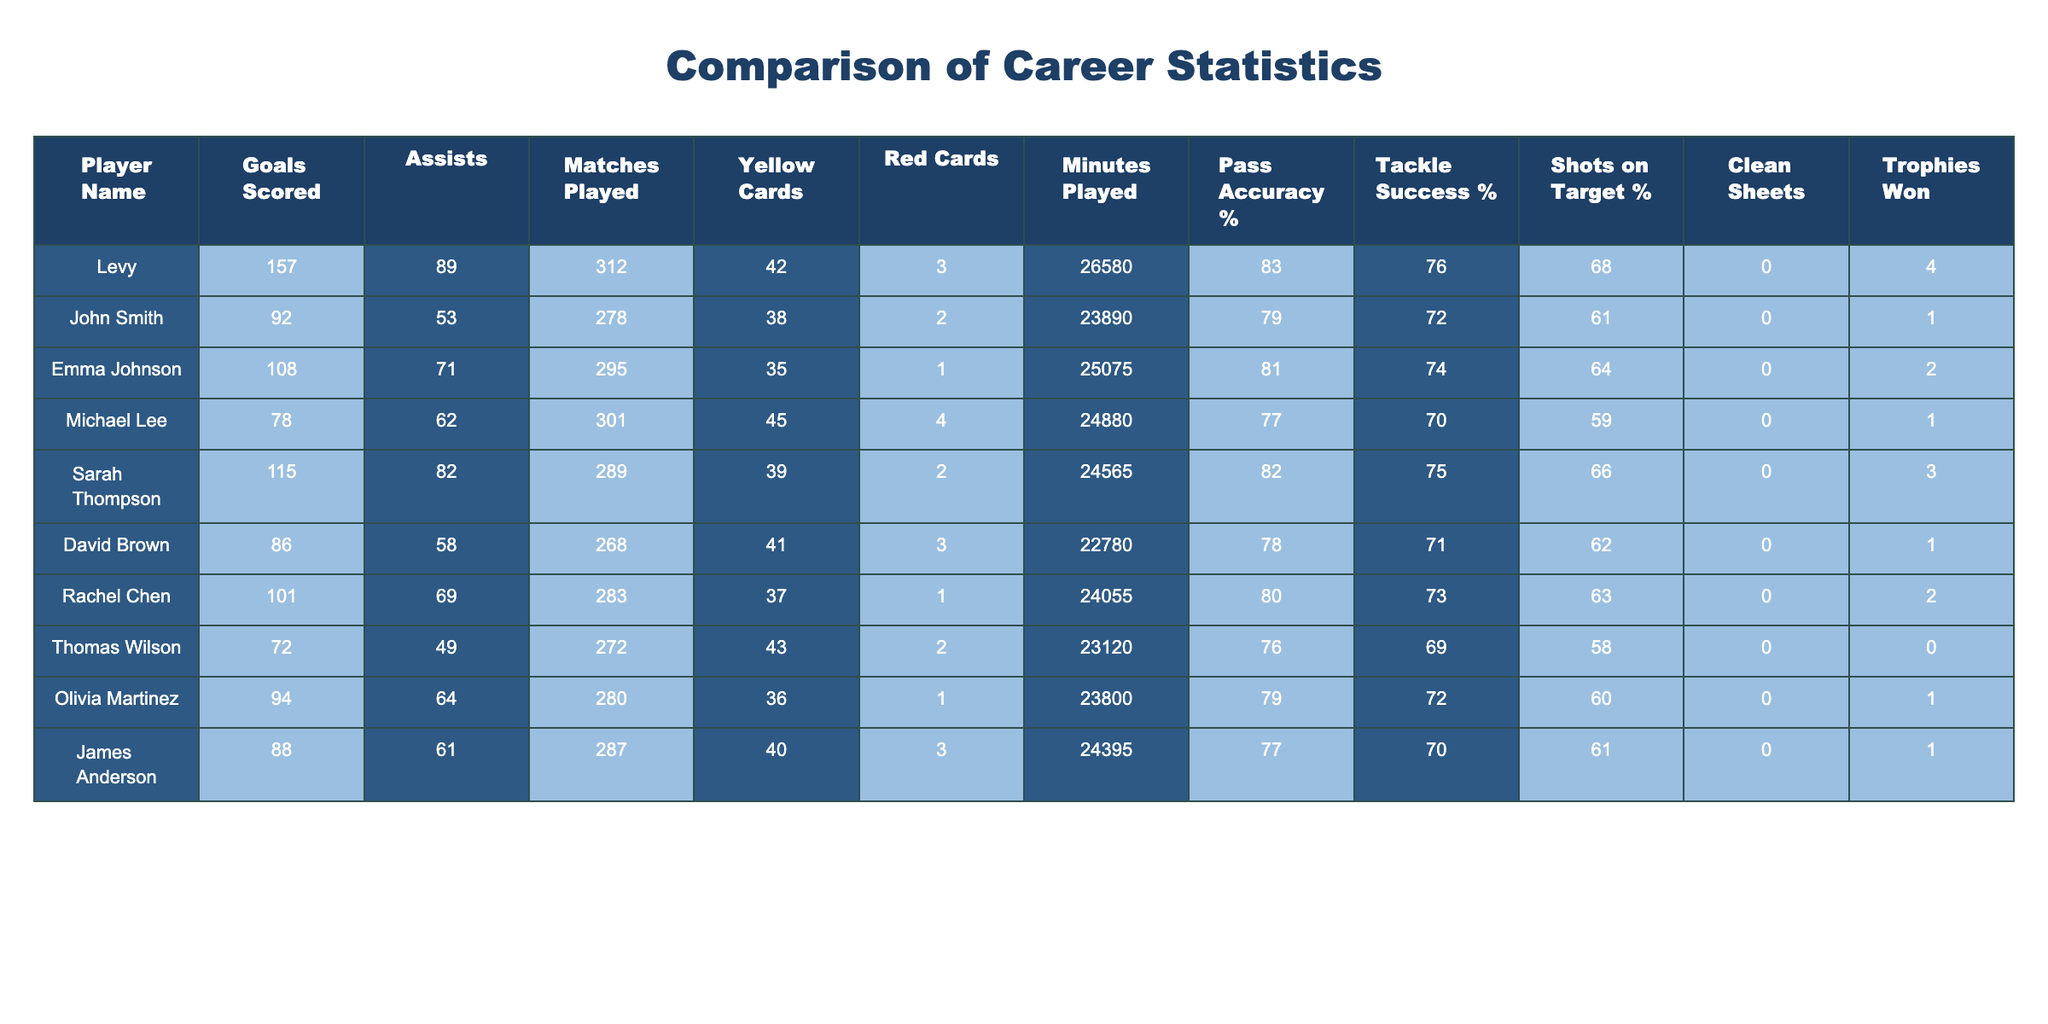What is Levy's total number of goals scored? Levy's goals scored can be directly retrieved from the table, which shows that he has scored 157 goals.
Answer: 157 Who has the highest number of assists among the local footballers? Looking through the assists column in the local footballers' data, Emma Johnson has the highest number of assists, totaling 71.
Answer: Emma Johnson What is the average number of goals scored by the local footballers? To find the average, we sum the total goals scored by the local footballers (92 + 108 + 78 + 115 + 86 + 101 + 72 + 94 + 88) = 840. There are 9 players, so the average is 840/9 ≈ 93.33.
Answer: 93.33 How many total yellow cards did Levy and local footballers receive combined? The total yellow cards can be found by summing Levy's yellow cards (42) with the yellow cards of local footballers (38 + 35 + 45 + 39 + 41 + 37 + 43 + 36 + 40) = 387. Thus, the combined total is 42 + 387 = 429.
Answer: 429 Does Rachel Chen have more goals than Michael Lee? Rachel Chen has scored 101 goals, while Michael Lee has scored 78 goals. Since 101 is greater than 78, Rachel Chen has more goals than Michael Lee.
Answer: Yes What percentage of shots on target does Levy have compared to the average of local footballers? Levy's shots on target percentage is 68%. The average for local footballers is calculated as (61 + 64 + 59 + 66 + 62 + 63 + 58 + 60 + 61) = 611; thus, it's 611/9 ≈ 67.89%. Since 68% is greater than 67.89%, Levy has a higher percentage than the average.
Answer: Yes What is the total number of matches played by all the players combined? The total matches played can be obtained by adding Levy's matches (312) to all the local footballers (278 + 295 + 301 + 289 + 268 + 283 + 272 + 280 + 287) = 2541. Therefore, the combined total is 312 + 2541 = 2853.
Answer: 2853 Which player has the most trophies won? By examining the trophies won column, Levy has 4 trophies, which is more than any other player. The highest number among local footballers is 3 trophies by Sarah Thompson. Therefore, Levy has the most trophies.
Answer: Levy Is the pass accuracy rate of Emma Johnson higher than that of David Brown? Emma Johnson has a pass accuracy rate of 81%, whereas David Brown's is 78%. Since 81% is greater than 78%, Emma Johnson has a higher pass accuracy rate.
Answer: Yes What is the difference in minutes played between Levy and Thomas Wilson? Levy's minutes played is 26580, while Thomas Wilson's is 23120. The difference is calculated as 26580 - 23120 = 3460 minutes.
Answer: 3460 